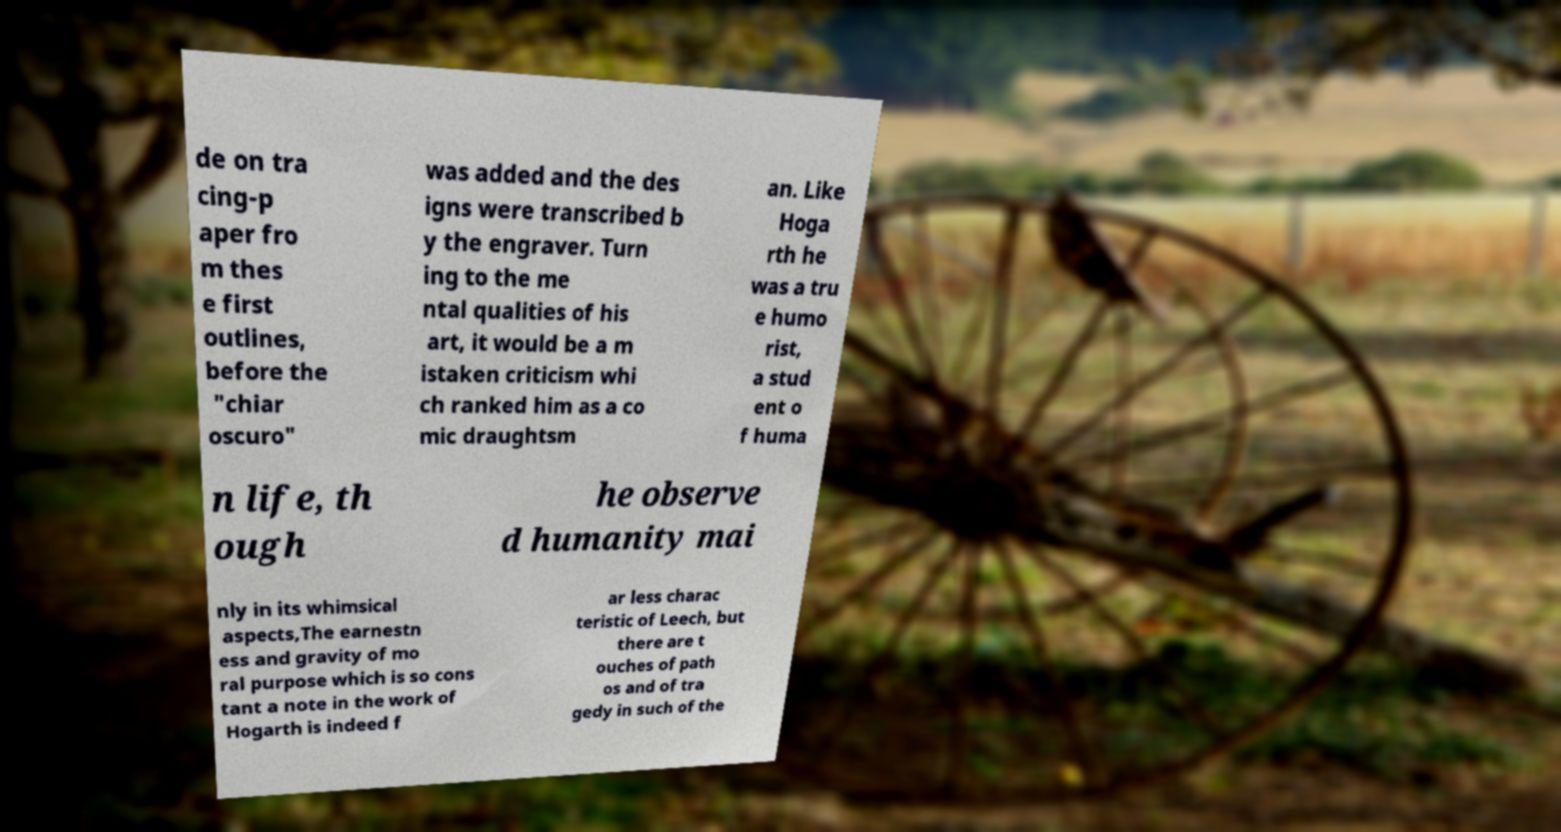Could you extract and type out the text from this image? de on tra cing-p aper fro m thes e first outlines, before the "chiar oscuro" was added and the des igns were transcribed b y the engraver. Turn ing to the me ntal qualities of his art, it would be a m istaken criticism whi ch ranked him as a co mic draughtsm an. Like Hoga rth he was a tru e humo rist, a stud ent o f huma n life, th ough he observe d humanity mai nly in its whimsical aspects,The earnestn ess and gravity of mo ral purpose which is so cons tant a note in the work of Hogarth is indeed f ar less charac teristic of Leech, but there are t ouches of path os and of tra gedy in such of the 